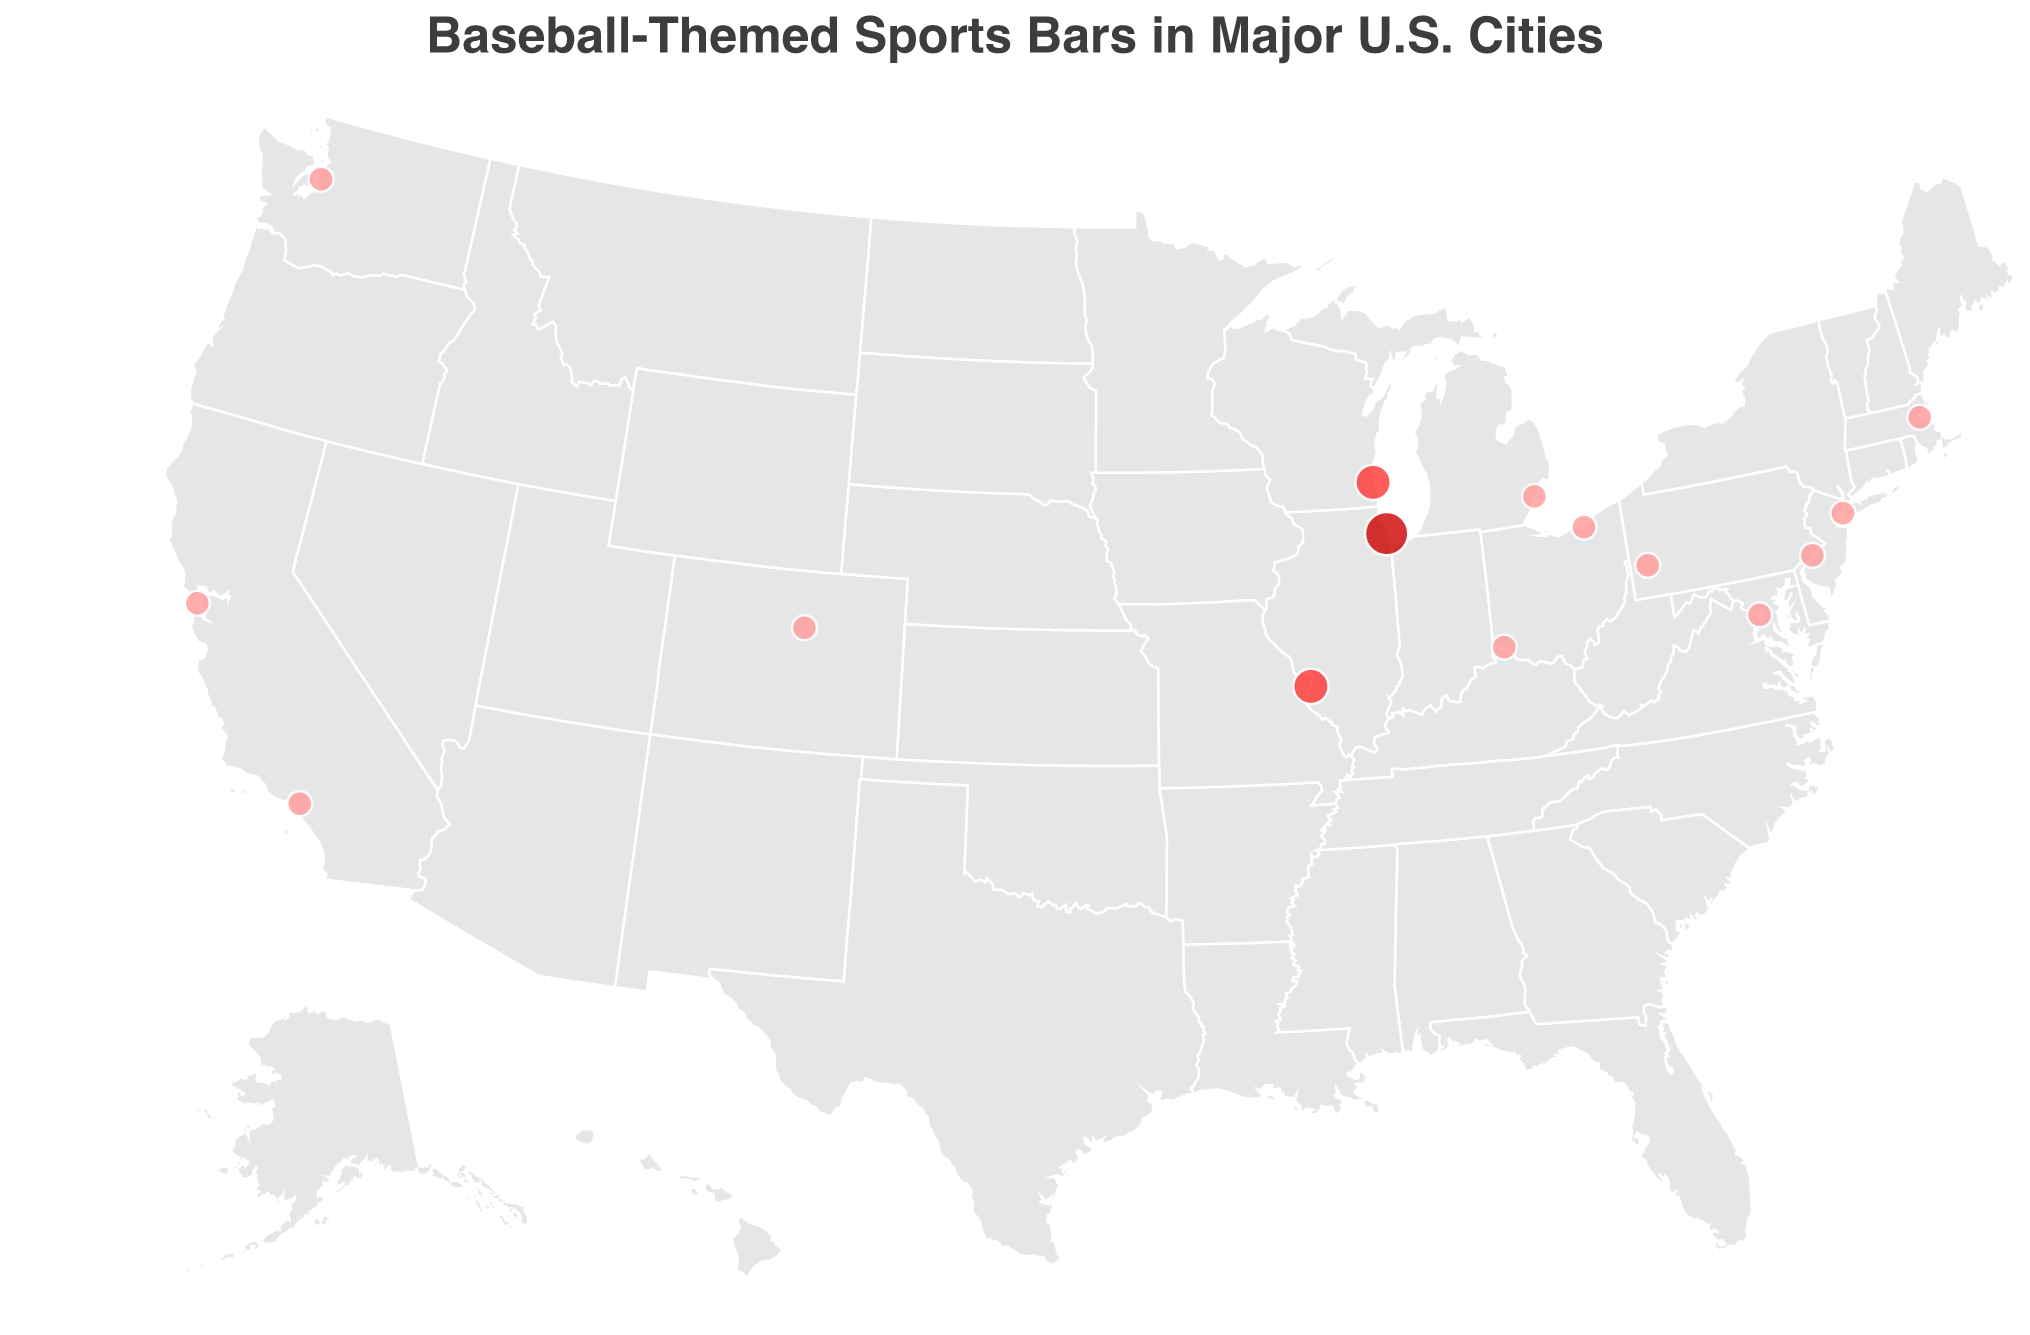What's the title of the figure? The title of the figure is displayed prominently at the top of the plot, typically larger in font size and often in bold. We can see that this figure is titled "Baseball-Themed Sports Bars in Major U.S. Cities".
Answer: Baseball-Themed Sports Bars in Major U.S. Cities Which city has the highest level of Cubs memorabilia? By looking at the size and color of the circles representing the memorabilia intensity, we notice that the largest and darkest red circle corresponds to Chicago.
Answer: Chicago How many cities feature bars with medium levels of Cubs memorabilia? In the plot, medium levels of Cubs memorabilia are represented by circles of medium size and the second darkest red color. By counting these circles, we see they appear in two cities: St. Louis and Milwaukee.
Answer: 2 Is there any city on the West Coast represented in the plot? By examining the geographic distribution on the map, we notice that cities on the West Coast, such as Los Angeles, San Francisco, and Seattle, are included.
Answer: Yes Which city on the East Coast has a bar with only a low level of Cubs memorabilia? By focusing on the East Coast and looking at the colors and sizes of the circles, we observe that New York, Boston, Philadelphia, and Washington D.C. all have bars with a low level of Cubs memorabilia.
Answer: Multiple cities Which city features the bar named "Murphy's Bleachers"? The tooltip information reveals the names of the bars, and by finding "Murphy's Bleachers", we see it is located in Chicago.
Answer: Chicago Compare the intensity of Cubs memorabilia between St. Louis and Chicago. By looking at the size and color of the circles for both cities, we see Chicago's circle is larger and darker red (high memorabilia) compared to St. Louis's medium-size and medium red circle (medium memorabilia).
Answer: Chicago has higher memorabilia What is the geographical spread of all the baseball-themed bars shown? Observing the plot, which uses longitude and latitude coordinates, we see that the bars are spread across the country, from Seattle on the West Coast to Boston on the East Coast, and from Chicago in the Midwest to Los Angeles in the Southwest.
Answer: Nationwide Explain the relationship between the color intensity and the size of the circles in the plot. The plot uses both color and size to indicate levels of Cubs memorabilia, where darker and larger circles represent higher levels, and lighter and smaller circles represent lower memorabilia levels. Therefore, size and color intensity both increase with higher memorabilia levels.
Answer: Direct correlation 